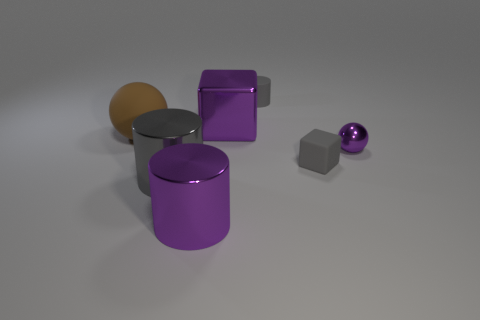Are there fewer large red spheres than large purple metal cubes? yes 